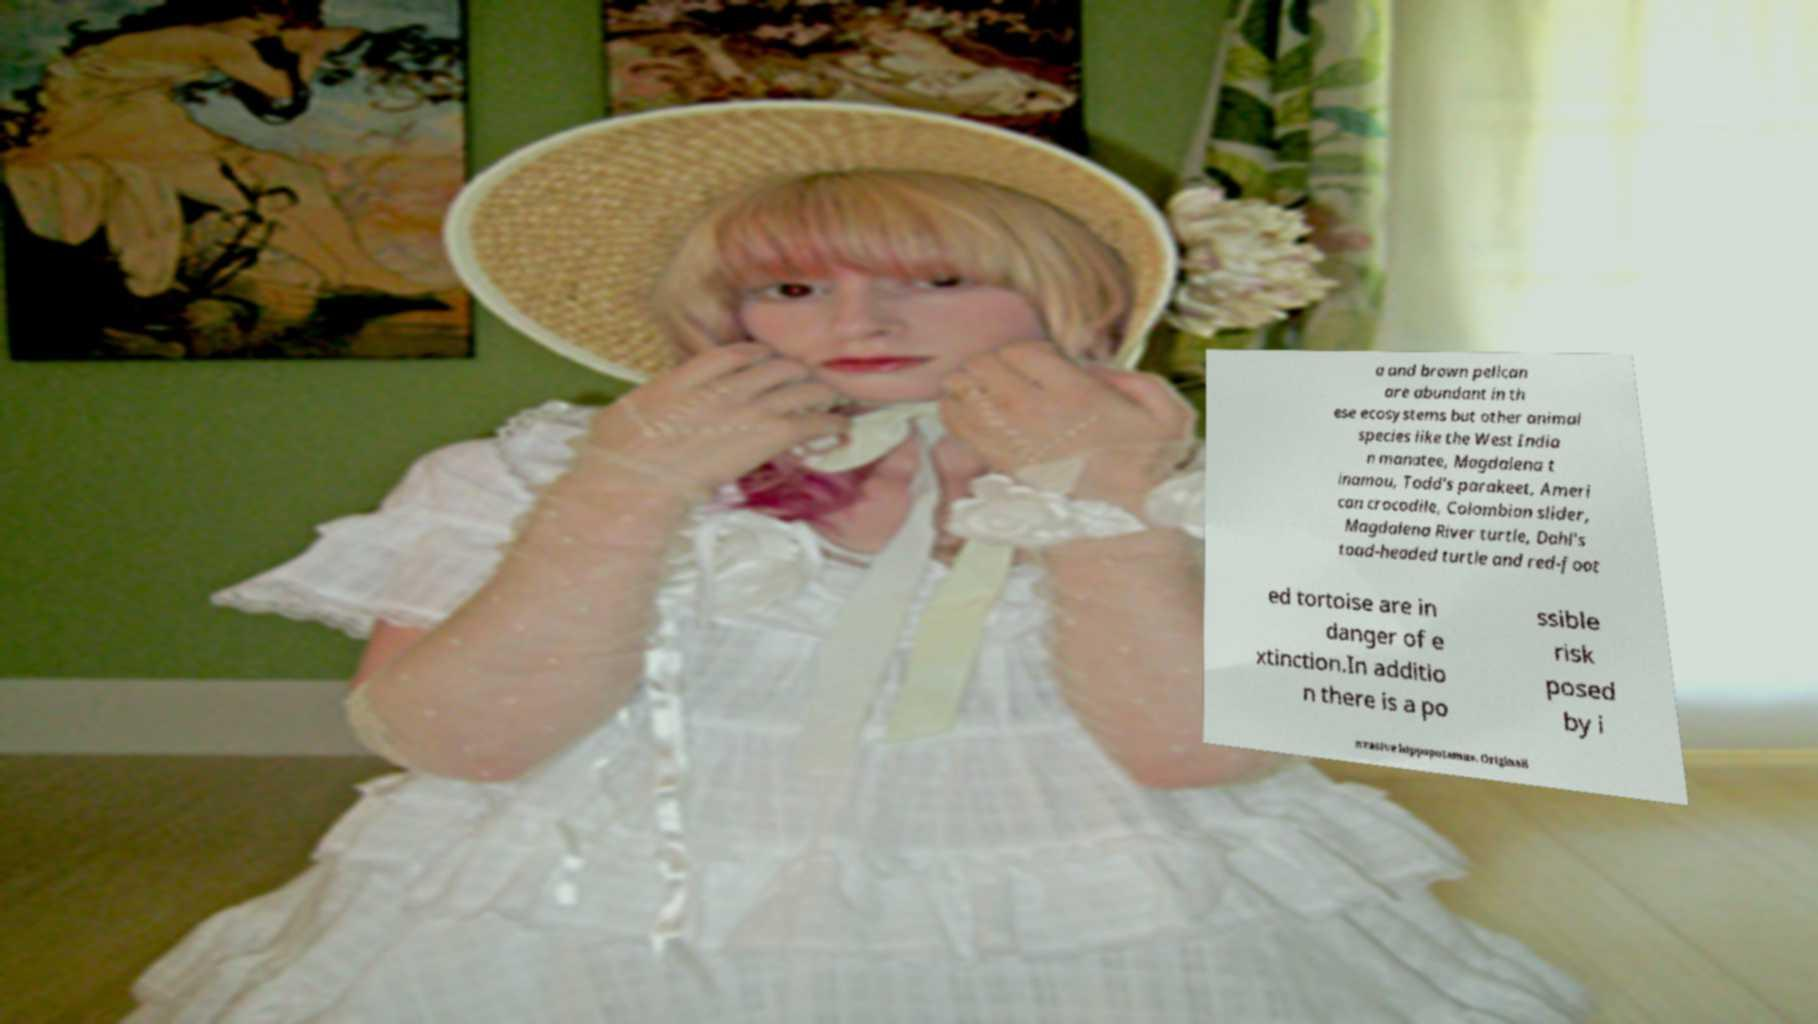Can you read and provide the text displayed in the image?This photo seems to have some interesting text. Can you extract and type it out for me? a and brown pelican are abundant in th ese ecosystems but other animal species like the West India n manatee, Magdalena t inamou, Todd's parakeet, Ameri can crocodile, Colombian slider, Magdalena River turtle, Dahl's toad-headed turtle and red-foot ed tortoise are in danger of e xtinction.In additio n there is a po ssible risk posed by i nvasive hippopotamus. Originall 